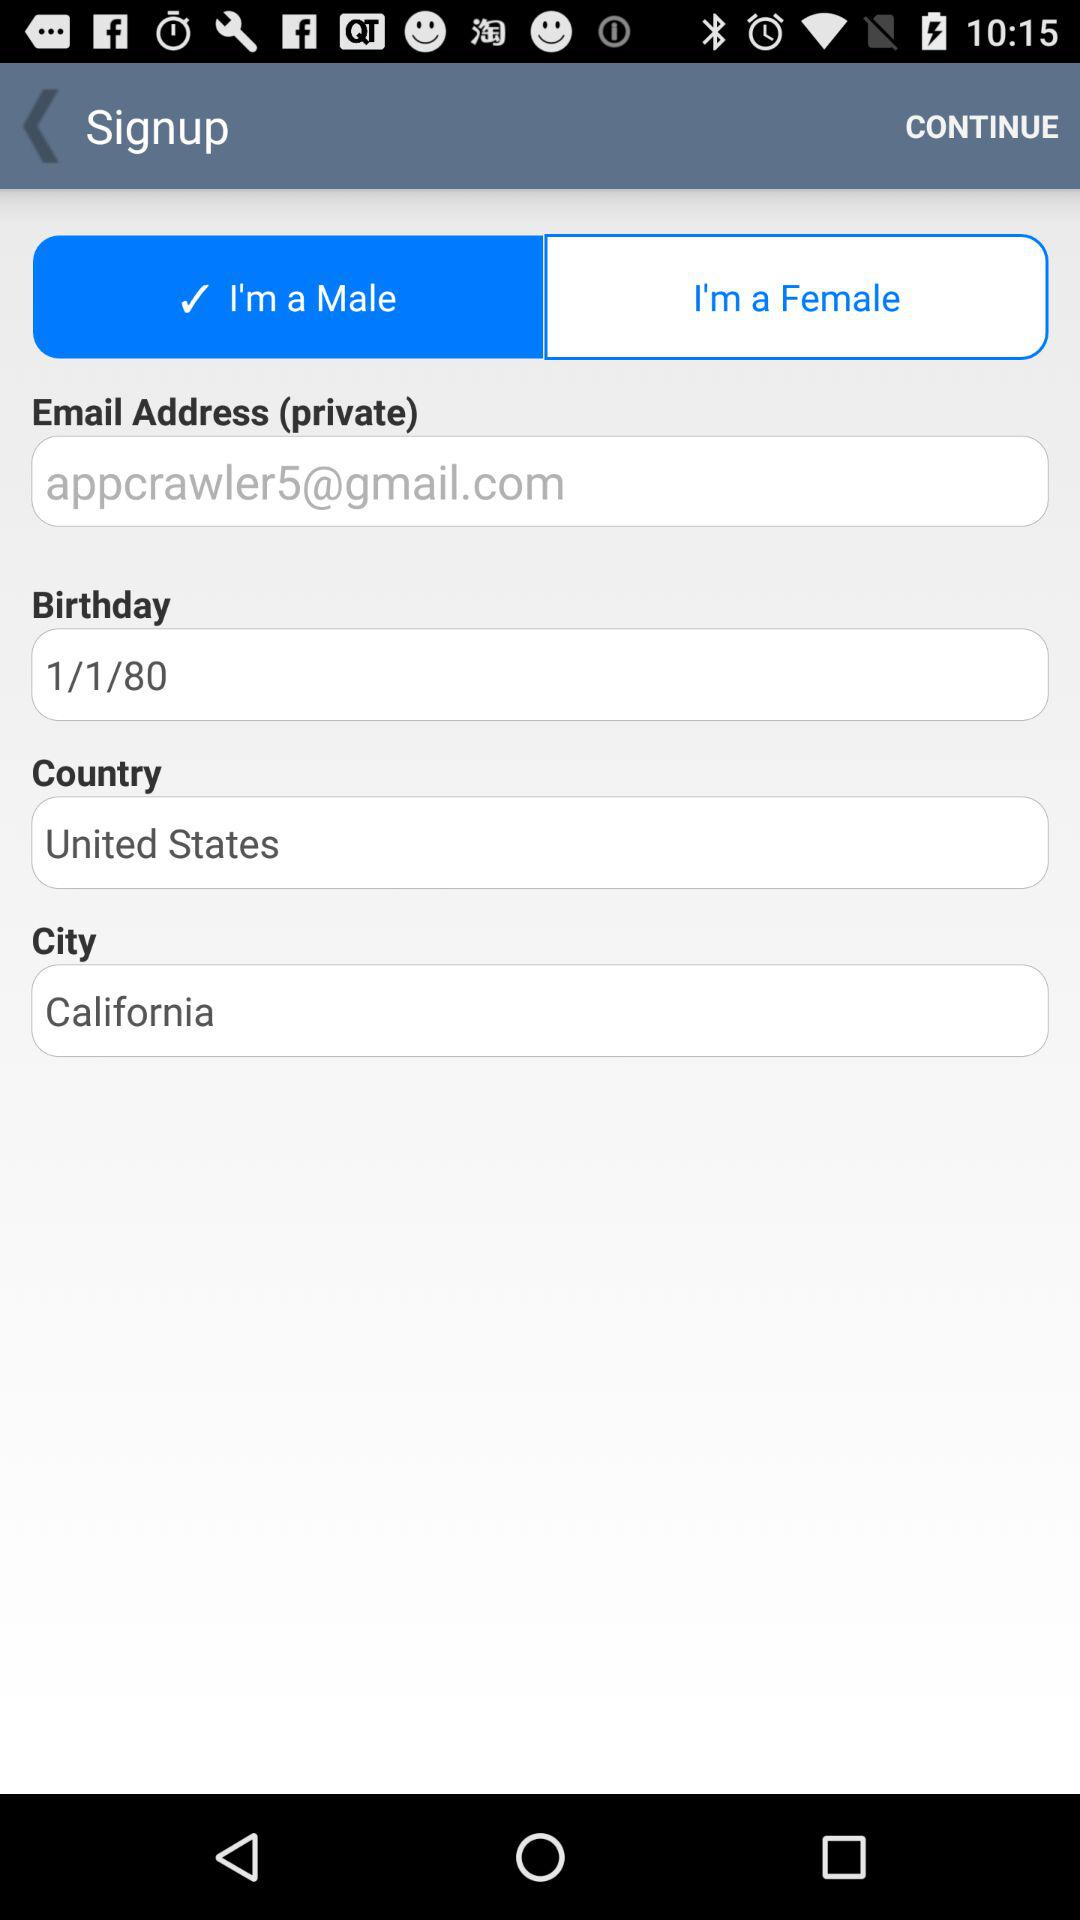Where does the user live? The user lives in the United States. 